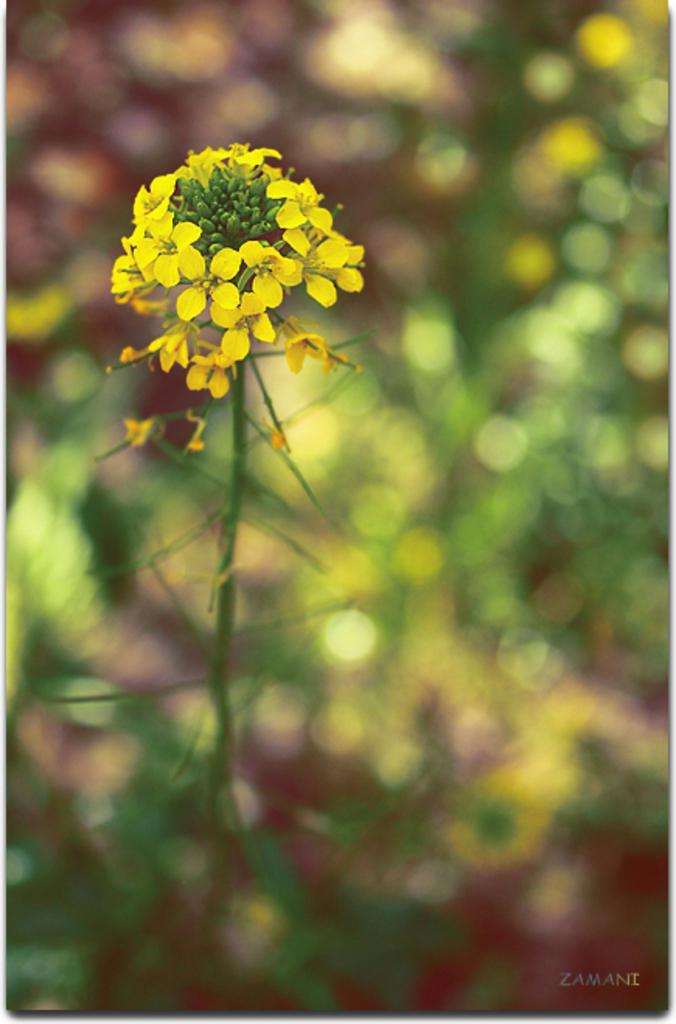Where was the image taken? The image was taken outdoors. What can be seen in the background of the image? There are plants in the background of the image. What type of plant is the main focus of the image? There is a plant with yellow flowers in the middle of the image. What type of coil is visible in the image? There is no coil present in the image. How does the daughter interact with the plant in the image? There is no daughter present in the image, so it is not possible to describe any interaction with the plant. 